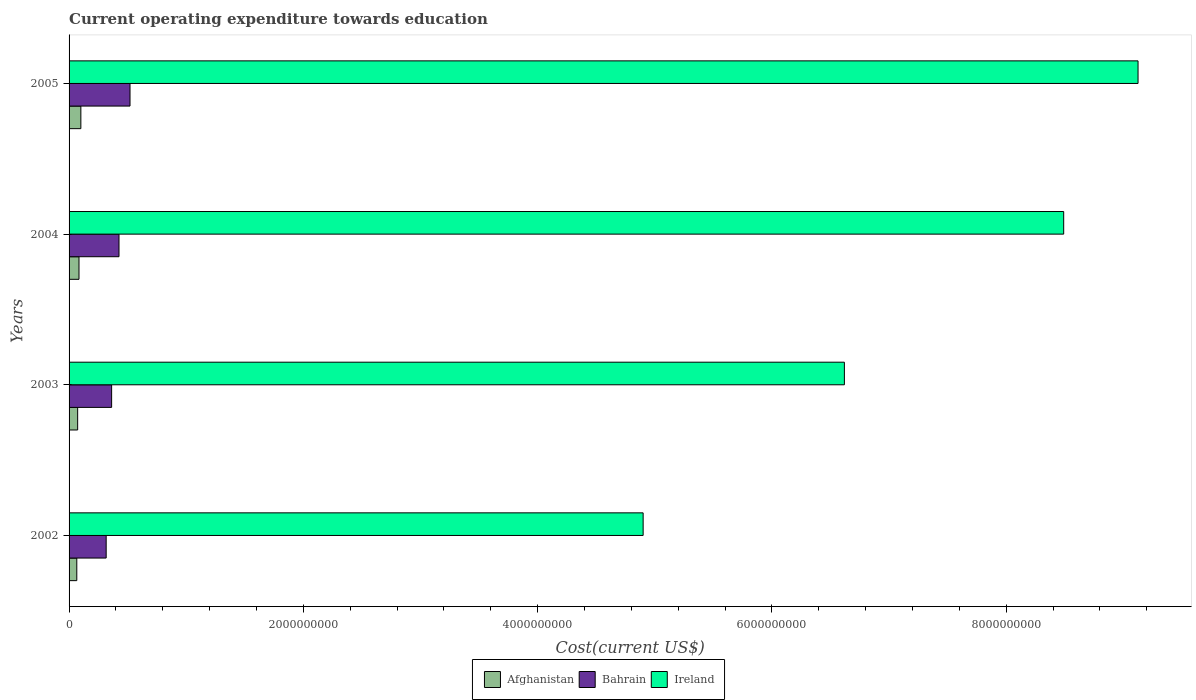How many different coloured bars are there?
Make the answer very short. 3. How many groups of bars are there?
Give a very brief answer. 4. Are the number of bars per tick equal to the number of legend labels?
Keep it short and to the point. Yes. How many bars are there on the 2nd tick from the bottom?
Offer a very short reply. 3. What is the label of the 2nd group of bars from the top?
Provide a short and direct response. 2004. In how many cases, is the number of bars for a given year not equal to the number of legend labels?
Make the answer very short. 0. What is the expenditure towards education in Afghanistan in 2002?
Offer a very short reply. 6.59e+07. Across all years, what is the maximum expenditure towards education in Ireland?
Offer a very short reply. 9.13e+09. Across all years, what is the minimum expenditure towards education in Ireland?
Offer a very short reply. 4.90e+09. In which year was the expenditure towards education in Bahrain maximum?
Your answer should be compact. 2005. What is the total expenditure towards education in Afghanistan in the graph?
Provide a succinct answer. 3.24e+08. What is the difference between the expenditure towards education in Ireland in 2004 and that in 2005?
Offer a terse response. -6.35e+08. What is the difference between the expenditure towards education in Bahrain in 2004 and the expenditure towards education in Ireland in 2002?
Provide a short and direct response. -4.47e+09. What is the average expenditure towards education in Bahrain per year?
Your answer should be very brief. 4.07e+08. In the year 2002, what is the difference between the expenditure towards education in Bahrain and expenditure towards education in Afghanistan?
Give a very brief answer. 2.51e+08. In how many years, is the expenditure towards education in Bahrain greater than 5600000000 US$?
Provide a short and direct response. 0. What is the ratio of the expenditure towards education in Bahrain in 2003 to that in 2005?
Offer a terse response. 0.7. What is the difference between the highest and the second highest expenditure towards education in Ireland?
Make the answer very short. 6.35e+08. What is the difference between the highest and the lowest expenditure towards education in Afghanistan?
Your answer should be compact. 3.47e+07. In how many years, is the expenditure towards education in Bahrain greater than the average expenditure towards education in Bahrain taken over all years?
Keep it short and to the point. 2. Is the sum of the expenditure towards education in Bahrain in 2004 and 2005 greater than the maximum expenditure towards education in Ireland across all years?
Your answer should be very brief. No. What does the 2nd bar from the top in 2003 represents?
Your response must be concise. Bahrain. What does the 3rd bar from the bottom in 2003 represents?
Provide a short and direct response. Ireland. Is it the case that in every year, the sum of the expenditure towards education in Afghanistan and expenditure towards education in Ireland is greater than the expenditure towards education in Bahrain?
Offer a very short reply. Yes. How many bars are there?
Keep it short and to the point. 12. Are the values on the major ticks of X-axis written in scientific E-notation?
Offer a very short reply. No. What is the title of the graph?
Keep it short and to the point. Current operating expenditure towards education. Does "Kazakhstan" appear as one of the legend labels in the graph?
Offer a very short reply. No. What is the label or title of the X-axis?
Your answer should be very brief. Cost(current US$). What is the Cost(current US$) of Afghanistan in 2002?
Provide a succinct answer. 6.59e+07. What is the Cost(current US$) in Bahrain in 2002?
Offer a terse response. 3.17e+08. What is the Cost(current US$) in Ireland in 2002?
Provide a succinct answer. 4.90e+09. What is the Cost(current US$) in Afghanistan in 2003?
Your answer should be very brief. 7.32e+07. What is the Cost(current US$) in Bahrain in 2003?
Your answer should be very brief. 3.63e+08. What is the Cost(current US$) of Ireland in 2003?
Ensure brevity in your answer.  6.62e+09. What is the Cost(current US$) in Afghanistan in 2004?
Ensure brevity in your answer.  8.47e+07. What is the Cost(current US$) in Bahrain in 2004?
Make the answer very short. 4.26e+08. What is the Cost(current US$) in Ireland in 2004?
Offer a very short reply. 8.49e+09. What is the Cost(current US$) of Afghanistan in 2005?
Offer a terse response. 1.01e+08. What is the Cost(current US$) in Bahrain in 2005?
Offer a terse response. 5.20e+08. What is the Cost(current US$) in Ireland in 2005?
Make the answer very short. 9.13e+09. Across all years, what is the maximum Cost(current US$) of Afghanistan?
Your response must be concise. 1.01e+08. Across all years, what is the maximum Cost(current US$) of Bahrain?
Offer a terse response. 5.20e+08. Across all years, what is the maximum Cost(current US$) in Ireland?
Your response must be concise. 9.13e+09. Across all years, what is the minimum Cost(current US$) in Afghanistan?
Your response must be concise. 6.59e+07. Across all years, what is the minimum Cost(current US$) of Bahrain?
Provide a short and direct response. 3.17e+08. Across all years, what is the minimum Cost(current US$) in Ireland?
Offer a very short reply. 4.90e+09. What is the total Cost(current US$) in Afghanistan in the graph?
Offer a very short reply. 3.24e+08. What is the total Cost(current US$) in Bahrain in the graph?
Your answer should be compact. 1.63e+09. What is the total Cost(current US$) of Ireland in the graph?
Make the answer very short. 2.91e+1. What is the difference between the Cost(current US$) of Afghanistan in 2002 and that in 2003?
Provide a short and direct response. -7.31e+06. What is the difference between the Cost(current US$) in Bahrain in 2002 and that in 2003?
Offer a very short reply. -4.66e+07. What is the difference between the Cost(current US$) in Ireland in 2002 and that in 2003?
Your response must be concise. -1.72e+09. What is the difference between the Cost(current US$) in Afghanistan in 2002 and that in 2004?
Offer a very short reply. -1.88e+07. What is the difference between the Cost(current US$) in Bahrain in 2002 and that in 2004?
Your answer should be compact. -1.09e+08. What is the difference between the Cost(current US$) in Ireland in 2002 and that in 2004?
Provide a short and direct response. -3.59e+09. What is the difference between the Cost(current US$) in Afghanistan in 2002 and that in 2005?
Provide a succinct answer. -3.47e+07. What is the difference between the Cost(current US$) in Bahrain in 2002 and that in 2005?
Make the answer very short. -2.04e+08. What is the difference between the Cost(current US$) in Ireland in 2002 and that in 2005?
Ensure brevity in your answer.  -4.22e+09. What is the difference between the Cost(current US$) in Afghanistan in 2003 and that in 2004?
Provide a short and direct response. -1.15e+07. What is the difference between the Cost(current US$) of Bahrain in 2003 and that in 2004?
Make the answer very short. -6.29e+07. What is the difference between the Cost(current US$) in Ireland in 2003 and that in 2004?
Ensure brevity in your answer.  -1.87e+09. What is the difference between the Cost(current US$) of Afghanistan in 2003 and that in 2005?
Your answer should be very brief. -2.74e+07. What is the difference between the Cost(current US$) of Bahrain in 2003 and that in 2005?
Provide a short and direct response. -1.57e+08. What is the difference between the Cost(current US$) of Ireland in 2003 and that in 2005?
Your answer should be compact. -2.51e+09. What is the difference between the Cost(current US$) in Afghanistan in 2004 and that in 2005?
Keep it short and to the point. -1.59e+07. What is the difference between the Cost(current US$) of Bahrain in 2004 and that in 2005?
Your response must be concise. -9.41e+07. What is the difference between the Cost(current US$) in Ireland in 2004 and that in 2005?
Provide a succinct answer. -6.35e+08. What is the difference between the Cost(current US$) of Afghanistan in 2002 and the Cost(current US$) of Bahrain in 2003?
Your answer should be compact. -2.97e+08. What is the difference between the Cost(current US$) of Afghanistan in 2002 and the Cost(current US$) of Ireland in 2003?
Make the answer very short. -6.55e+09. What is the difference between the Cost(current US$) in Bahrain in 2002 and the Cost(current US$) in Ireland in 2003?
Ensure brevity in your answer.  -6.30e+09. What is the difference between the Cost(current US$) of Afghanistan in 2002 and the Cost(current US$) of Bahrain in 2004?
Make the answer very short. -3.60e+08. What is the difference between the Cost(current US$) of Afghanistan in 2002 and the Cost(current US$) of Ireland in 2004?
Your answer should be compact. -8.42e+09. What is the difference between the Cost(current US$) in Bahrain in 2002 and the Cost(current US$) in Ireland in 2004?
Keep it short and to the point. -8.17e+09. What is the difference between the Cost(current US$) in Afghanistan in 2002 and the Cost(current US$) in Bahrain in 2005?
Give a very brief answer. -4.54e+08. What is the difference between the Cost(current US$) of Afghanistan in 2002 and the Cost(current US$) of Ireland in 2005?
Offer a very short reply. -9.06e+09. What is the difference between the Cost(current US$) in Bahrain in 2002 and the Cost(current US$) in Ireland in 2005?
Give a very brief answer. -8.81e+09. What is the difference between the Cost(current US$) of Afghanistan in 2003 and the Cost(current US$) of Bahrain in 2004?
Make the answer very short. -3.53e+08. What is the difference between the Cost(current US$) in Afghanistan in 2003 and the Cost(current US$) in Ireland in 2004?
Offer a terse response. -8.42e+09. What is the difference between the Cost(current US$) of Bahrain in 2003 and the Cost(current US$) of Ireland in 2004?
Keep it short and to the point. -8.13e+09. What is the difference between the Cost(current US$) of Afghanistan in 2003 and the Cost(current US$) of Bahrain in 2005?
Offer a very short reply. -4.47e+08. What is the difference between the Cost(current US$) in Afghanistan in 2003 and the Cost(current US$) in Ireland in 2005?
Keep it short and to the point. -9.05e+09. What is the difference between the Cost(current US$) in Bahrain in 2003 and the Cost(current US$) in Ireland in 2005?
Offer a very short reply. -8.76e+09. What is the difference between the Cost(current US$) in Afghanistan in 2004 and the Cost(current US$) in Bahrain in 2005?
Offer a very short reply. -4.36e+08. What is the difference between the Cost(current US$) in Afghanistan in 2004 and the Cost(current US$) in Ireland in 2005?
Make the answer very short. -9.04e+09. What is the difference between the Cost(current US$) in Bahrain in 2004 and the Cost(current US$) in Ireland in 2005?
Give a very brief answer. -8.70e+09. What is the average Cost(current US$) of Afghanistan per year?
Provide a succinct answer. 8.11e+07. What is the average Cost(current US$) of Bahrain per year?
Offer a very short reply. 4.07e+08. What is the average Cost(current US$) in Ireland per year?
Offer a very short reply. 7.28e+09. In the year 2002, what is the difference between the Cost(current US$) of Afghanistan and Cost(current US$) of Bahrain?
Provide a succinct answer. -2.51e+08. In the year 2002, what is the difference between the Cost(current US$) of Afghanistan and Cost(current US$) of Ireland?
Provide a short and direct response. -4.83e+09. In the year 2002, what is the difference between the Cost(current US$) of Bahrain and Cost(current US$) of Ireland?
Provide a short and direct response. -4.58e+09. In the year 2003, what is the difference between the Cost(current US$) in Afghanistan and Cost(current US$) in Bahrain?
Keep it short and to the point. -2.90e+08. In the year 2003, what is the difference between the Cost(current US$) of Afghanistan and Cost(current US$) of Ireland?
Offer a very short reply. -6.55e+09. In the year 2003, what is the difference between the Cost(current US$) of Bahrain and Cost(current US$) of Ireland?
Your answer should be very brief. -6.26e+09. In the year 2004, what is the difference between the Cost(current US$) of Afghanistan and Cost(current US$) of Bahrain?
Offer a very short reply. -3.41e+08. In the year 2004, what is the difference between the Cost(current US$) of Afghanistan and Cost(current US$) of Ireland?
Your response must be concise. -8.41e+09. In the year 2004, what is the difference between the Cost(current US$) of Bahrain and Cost(current US$) of Ireland?
Ensure brevity in your answer.  -8.06e+09. In the year 2005, what is the difference between the Cost(current US$) of Afghanistan and Cost(current US$) of Bahrain?
Keep it short and to the point. -4.20e+08. In the year 2005, what is the difference between the Cost(current US$) of Afghanistan and Cost(current US$) of Ireland?
Keep it short and to the point. -9.02e+09. In the year 2005, what is the difference between the Cost(current US$) of Bahrain and Cost(current US$) of Ireland?
Your answer should be very brief. -8.61e+09. What is the ratio of the Cost(current US$) of Afghanistan in 2002 to that in 2003?
Keep it short and to the point. 0.9. What is the ratio of the Cost(current US$) in Bahrain in 2002 to that in 2003?
Provide a succinct answer. 0.87. What is the ratio of the Cost(current US$) of Ireland in 2002 to that in 2003?
Offer a terse response. 0.74. What is the ratio of the Cost(current US$) of Afghanistan in 2002 to that in 2004?
Keep it short and to the point. 0.78. What is the ratio of the Cost(current US$) of Bahrain in 2002 to that in 2004?
Give a very brief answer. 0.74. What is the ratio of the Cost(current US$) of Ireland in 2002 to that in 2004?
Make the answer very short. 0.58. What is the ratio of the Cost(current US$) of Afghanistan in 2002 to that in 2005?
Provide a succinct answer. 0.66. What is the ratio of the Cost(current US$) of Bahrain in 2002 to that in 2005?
Offer a terse response. 0.61. What is the ratio of the Cost(current US$) of Ireland in 2002 to that in 2005?
Make the answer very short. 0.54. What is the ratio of the Cost(current US$) of Afghanistan in 2003 to that in 2004?
Your answer should be very brief. 0.86. What is the ratio of the Cost(current US$) of Bahrain in 2003 to that in 2004?
Keep it short and to the point. 0.85. What is the ratio of the Cost(current US$) of Ireland in 2003 to that in 2004?
Offer a terse response. 0.78. What is the ratio of the Cost(current US$) in Afghanistan in 2003 to that in 2005?
Offer a very short reply. 0.73. What is the ratio of the Cost(current US$) in Bahrain in 2003 to that in 2005?
Give a very brief answer. 0.7. What is the ratio of the Cost(current US$) of Ireland in 2003 to that in 2005?
Your answer should be compact. 0.73. What is the ratio of the Cost(current US$) of Afghanistan in 2004 to that in 2005?
Your answer should be compact. 0.84. What is the ratio of the Cost(current US$) of Bahrain in 2004 to that in 2005?
Ensure brevity in your answer.  0.82. What is the ratio of the Cost(current US$) of Ireland in 2004 to that in 2005?
Make the answer very short. 0.93. What is the difference between the highest and the second highest Cost(current US$) of Afghanistan?
Your answer should be very brief. 1.59e+07. What is the difference between the highest and the second highest Cost(current US$) in Bahrain?
Provide a short and direct response. 9.41e+07. What is the difference between the highest and the second highest Cost(current US$) of Ireland?
Your response must be concise. 6.35e+08. What is the difference between the highest and the lowest Cost(current US$) in Afghanistan?
Offer a terse response. 3.47e+07. What is the difference between the highest and the lowest Cost(current US$) of Bahrain?
Keep it short and to the point. 2.04e+08. What is the difference between the highest and the lowest Cost(current US$) in Ireland?
Provide a succinct answer. 4.22e+09. 